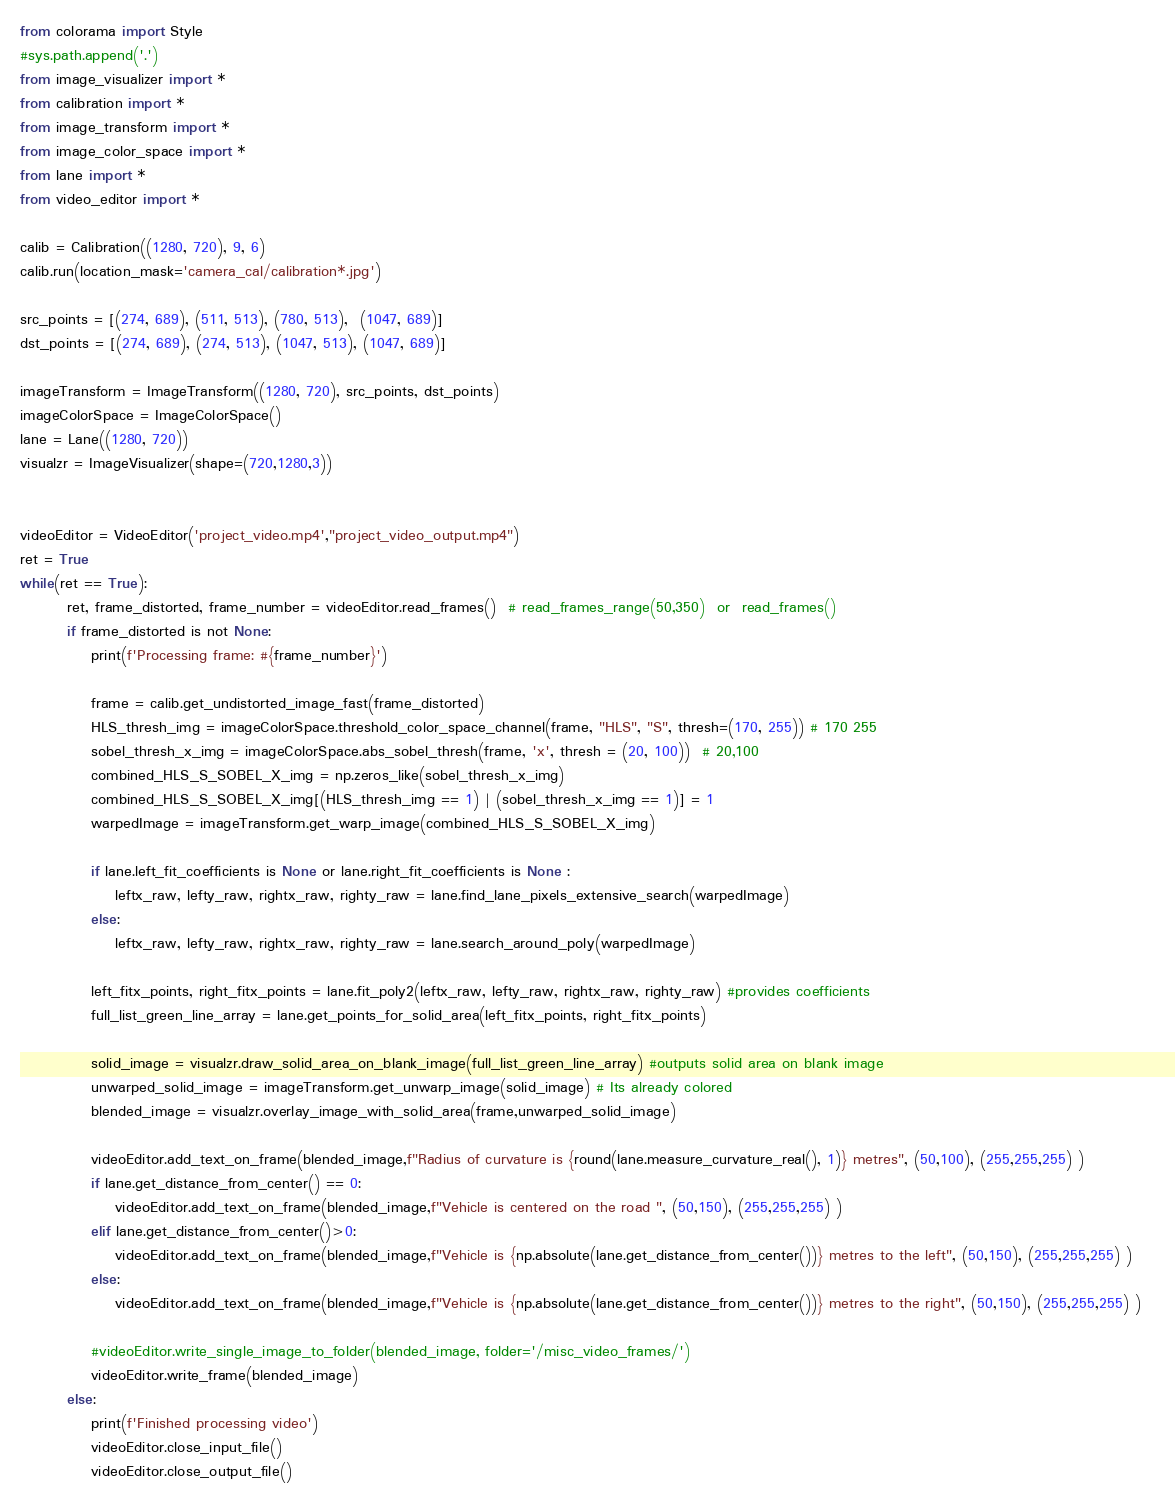Convert code to text. <code><loc_0><loc_0><loc_500><loc_500><_Python_>from colorama import Style
#sys.path.append('.')
from image_visualizer import *
from calibration import *
from image_transform import *
from image_color_space import *
from lane import *
from video_editor import *

calib = Calibration((1280, 720), 9, 6)
calib.run(location_mask='camera_cal/calibration*.jpg')

src_points = [(274, 689), (511, 513), (780, 513),  (1047, 689)] 
dst_points = [(274, 689), (274, 513), (1047, 513), (1047, 689)] 

imageTransform = ImageTransform((1280, 720), src_points, dst_points)
imageColorSpace = ImageColorSpace()
lane = Lane((1280, 720))
visualzr = ImageVisualizer(shape=(720,1280,3))


videoEditor = VideoEditor('project_video.mp4',"project_video_output.mp4")
ret = True
while(ret == True):        
        ret, frame_distorted, frame_number = videoEditor.read_frames()  # read_frames_range(50,350)  or  read_frames()
        if frame_distorted is not None:
            print(f'Processing frame: #{frame_number}')

            frame = calib.get_undistorted_image_fast(frame_distorted)
            HLS_thresh_img = imageColorSpace.threshold_color_space_channel(frame, "HLS", "S", thresh=(170, 255)) # 170 255
            sobel_thresh_x_img = imageColorSpace.abs_sobel_thresh(frame, 'x', thresh = (20, 100))  # 20,100
            combined_HLS_S_SOBEL_X_img = np.zeros_like(sobel_thresh_x_img)
            combined_HLS_S_SOBEL_X_img[(HLS_thresh_img == 1) | (sobel_thresh_x_img == 1)] = 1
            warpedImage = imageTransform.get_warp_image(combined_HLS_S_SOBEL_X_img)

            if lane.left_fit_coefficients is None or lane.right_fit_coefficients is None :
                leftx_raw, lefty_raw, rightx_raw, righty_raw = lane.find_lane_pixels_extensive_search(warpedImage)
            else:
                leftx_raw, lefty_raw, rightx_raw, righty_raw = lane.search_around_poly(warpedImage)

            left_fitx_points, right_fitx_points = lane.fit_poly2(leftx_raw, lefty_raw, rightx_raw, righty_raw) #provides coefficients
            full_list_green_line_array = lane.get_points_for_solid_area(left_fitx_points, right_fitx_points)

            solid_image = visualzr.draw_solid_area_on_blank_image(full_list_green_line_array) #outputs solid area on blank image            
            unwarped_solid_image = imageTransform.get_unwarp_image(solid_image) # Its already colored            
            blended_image = visualzr.overlay_image_with_solid_area(frame,unwarped_solid_image)
            
            videoEditor.add_text_on_frame(blended_image,f"Radius of curvature is {round(lane.measure_curvature_real(), 1)} metres", (50,100), (255,255,255) )            
            if lane.get_distance_from_center() == 0:
                videoEditor.add_text_on_frame(blended_image,f"Vehicle is centered on the road ", (50,150), (255,255,255) )
            elif lane.get_distance_from_center()>0:
                videoEditor.add_text_on_frame(blended_image,f"Vehicle is {np.absolute(lane.get_distance_from_center())} metres to the left", (50,150), (255,255,255) )
            else:
                videoEditor.add_text_on_frame(blended_image,f"Vehicle is {np.absolute(lane.get_distance_from_center())} metres to the right", (50,150), (255,255,255) )

            #videoEditor.write_single_image_to_folder(blended_image, folder='/misc_video_frames/')         
            videoEditor.write_frame(blended_image)            
        else:
            print(f'Finished processing video')
            videoEditor.close_input_file()
            videoEditor.close_output_file()
</code> 